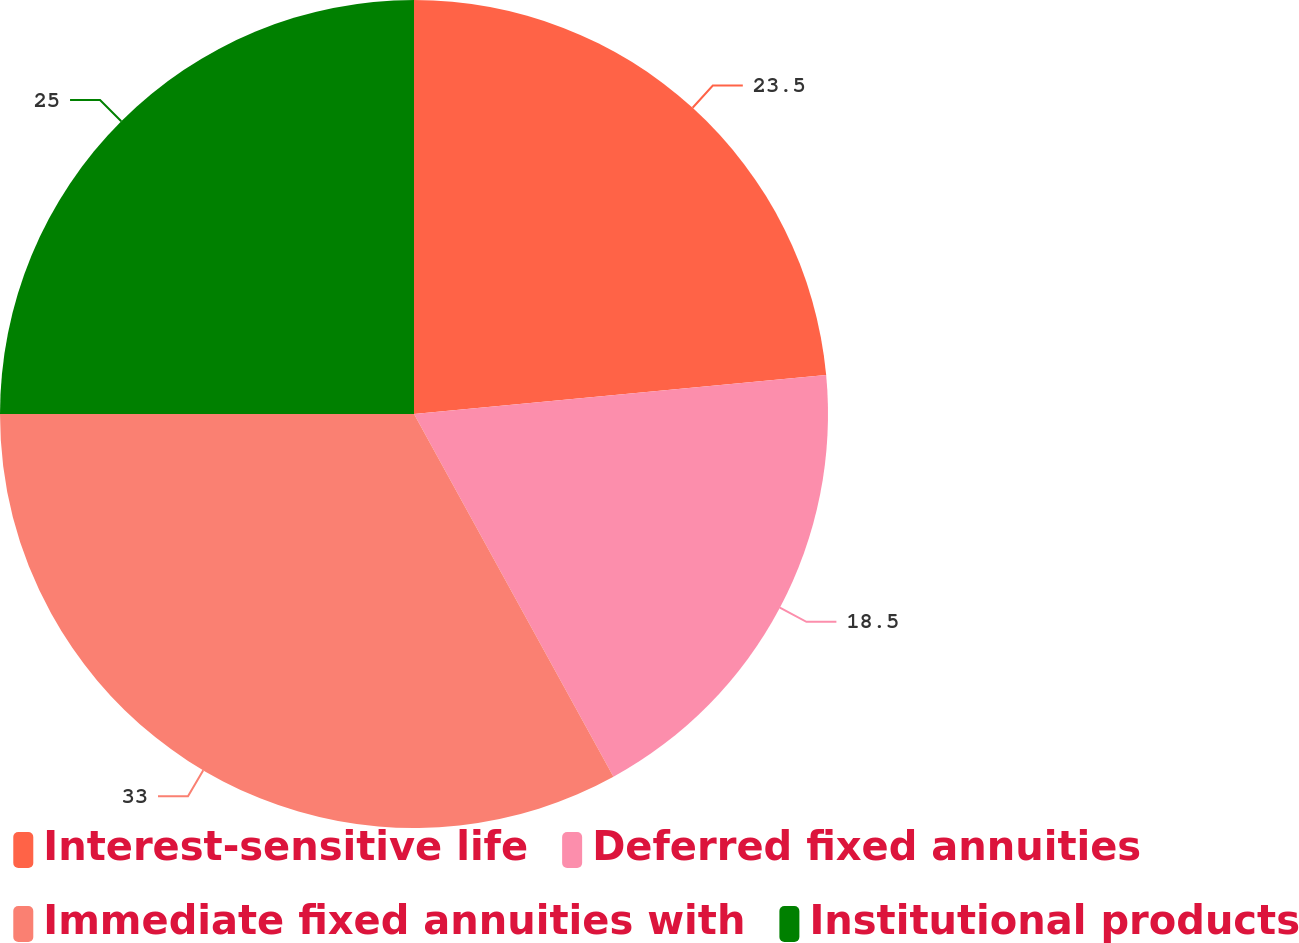<chart> <loc_0><loc_0><loc_500><loc_500><pie_chart><fcel>Interest-sensitive life<fcel>Deferred fixed annuities<fcel>Immediate fixed annuities with<fcel>Institutional products<nl><fcel>23.5%<fcel>18.5%<fcel>33.0%<fcel>25.0%<nl></chart> 